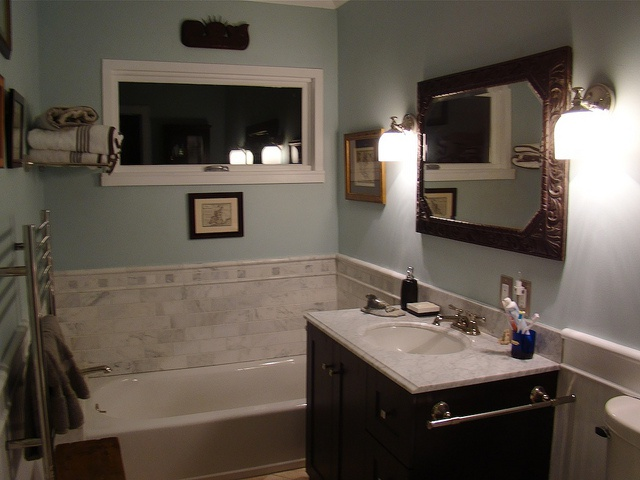Describe the objects in this image and their specific colors. I can see toilet in black and darkgray tones, sink in black, darkgray, and gray tones, bottle in black, gray, and darkgray tones, toothbrush in black, gray, maroon, and darkgray tones, and toothbrush in black and gray tones in this image. 